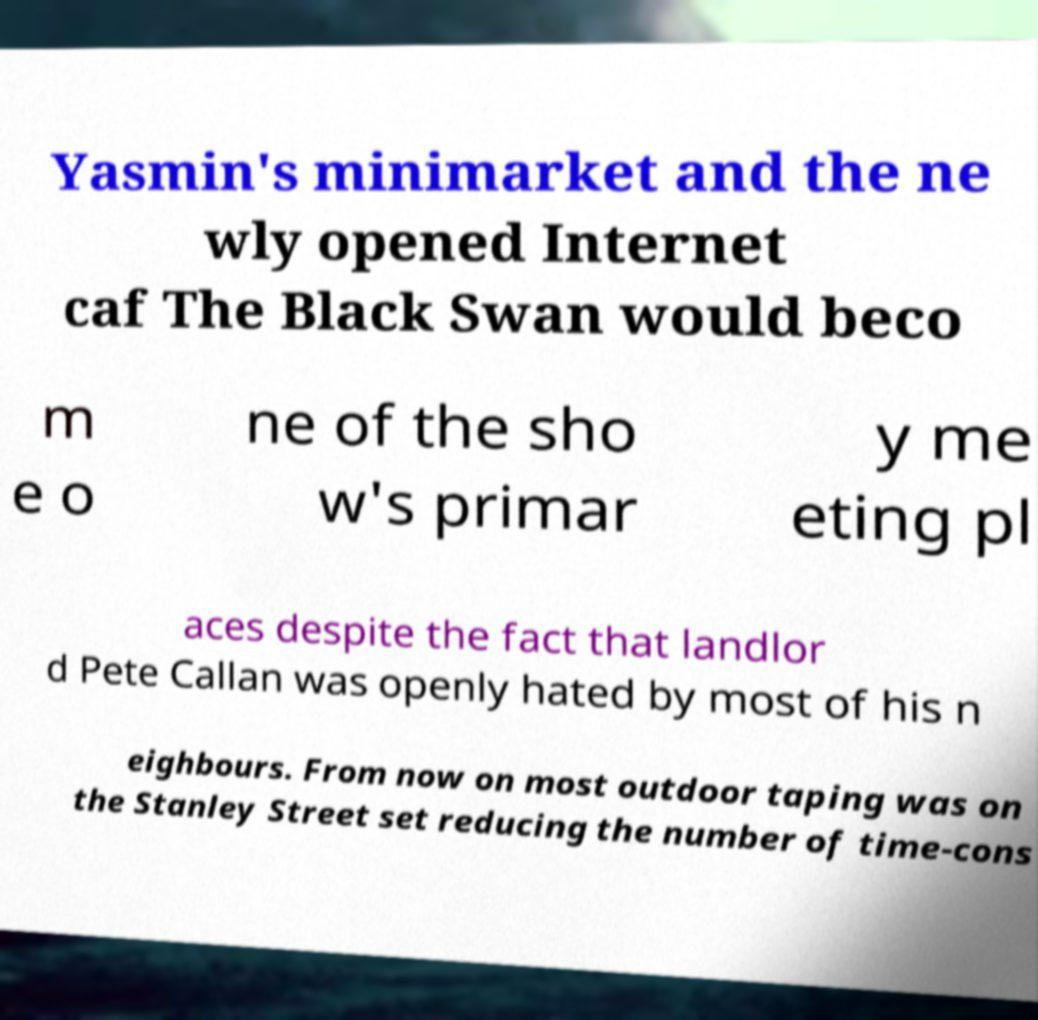What messages or text are displayed in this image? I need them in a readable, typed format. Yasmin's minimarket and the ne wly opened Internet caf The Black Swan would beco m e o ne of the sho w's primar y me eting pl aces despite the fact that landlor d Pete Callan was openly hated by most of his n eighbours. From now on most outdoor taping was on the Stanley Street set reducing the number of time-cons 